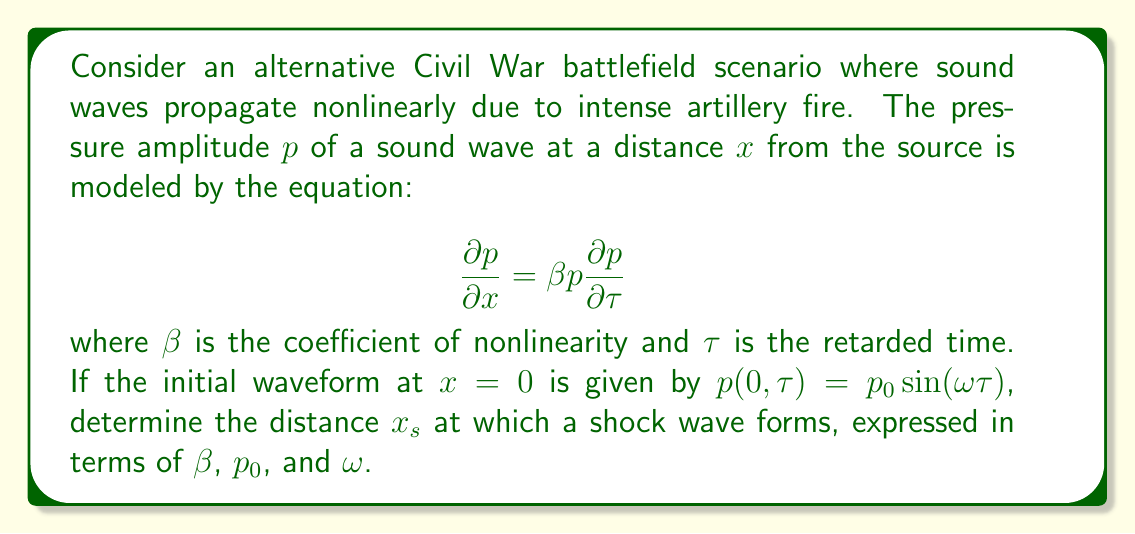Give your solution to this math problem. To solve this problem, we'll follow these steps:

1) The given equation is a nonlinear partial differential equation known as the inviscid Burgers' equation. It describes the propagation of finite-amplitude sound waves.

2) For a sinusoidal initial condition, the shock formation distance can be derived analytically.

3) The shock forms when the wave profile becomes vertical, which occurs when $\frac{\partial p}{\partial \tau} \to \infty$.

4) For the given initial condition, $p(0,\tau) = p_0 \sin(\omega \tau)$, we can find $\frac{\partial p}{\partial \tau}$ at $x=0$:

   $$\left.\frac{\partial p}{\partial \tau}\right|_{x=0} = p_0 \omega \cos(\omega \tau)$$

5) The maximum value of this occurs when $\cos(\omega \tau) = 1$, giving:

   $$\left.\frac{\partial p}{\partial \tau}\right|_{x=0,max} = p_0 \omega$$

6) As the wave propagates, this maximum slope increases. The shock forms when:

   $$\frac{1}{\left.\frac{\partial p}{\partial \tau}\right|_{x=0,max}} - \beta x_s = 0$$

7) Substituting the maximum slope:

   $$\frac{1}{p_0 \omega} - \beta x_s = 0$$

8) Solving for $x_s$:

   $$x_s = \frac{1}{\beta p_0 \omega}$$

This expression gives the shock formation distance in terms of the required parameters.
Answer: $x_s = \frac{1}{\beta p_0 \omega}$ 